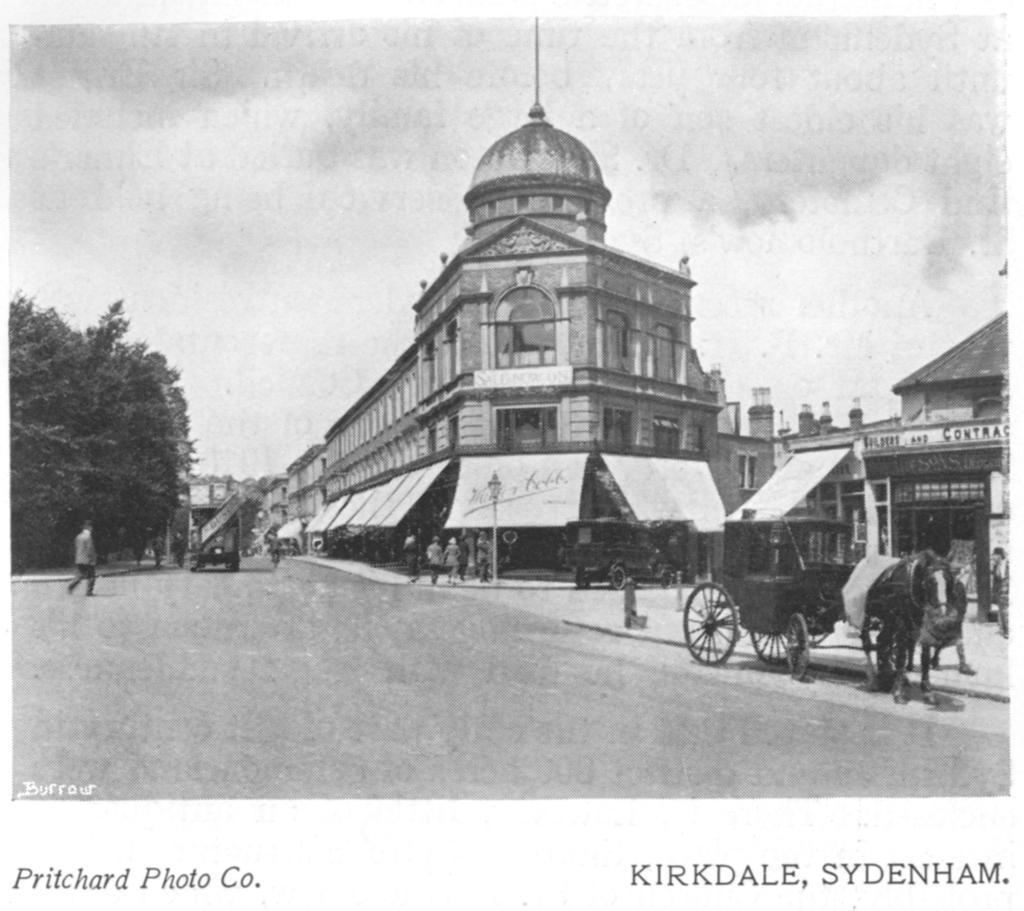Describe this image in one or two sentences. In the center of the image there are buildings. At the bottom we can see horse cart and a car on the road. In the center there are people. On the left we can see a man walking. In the background there are trees and sky. 